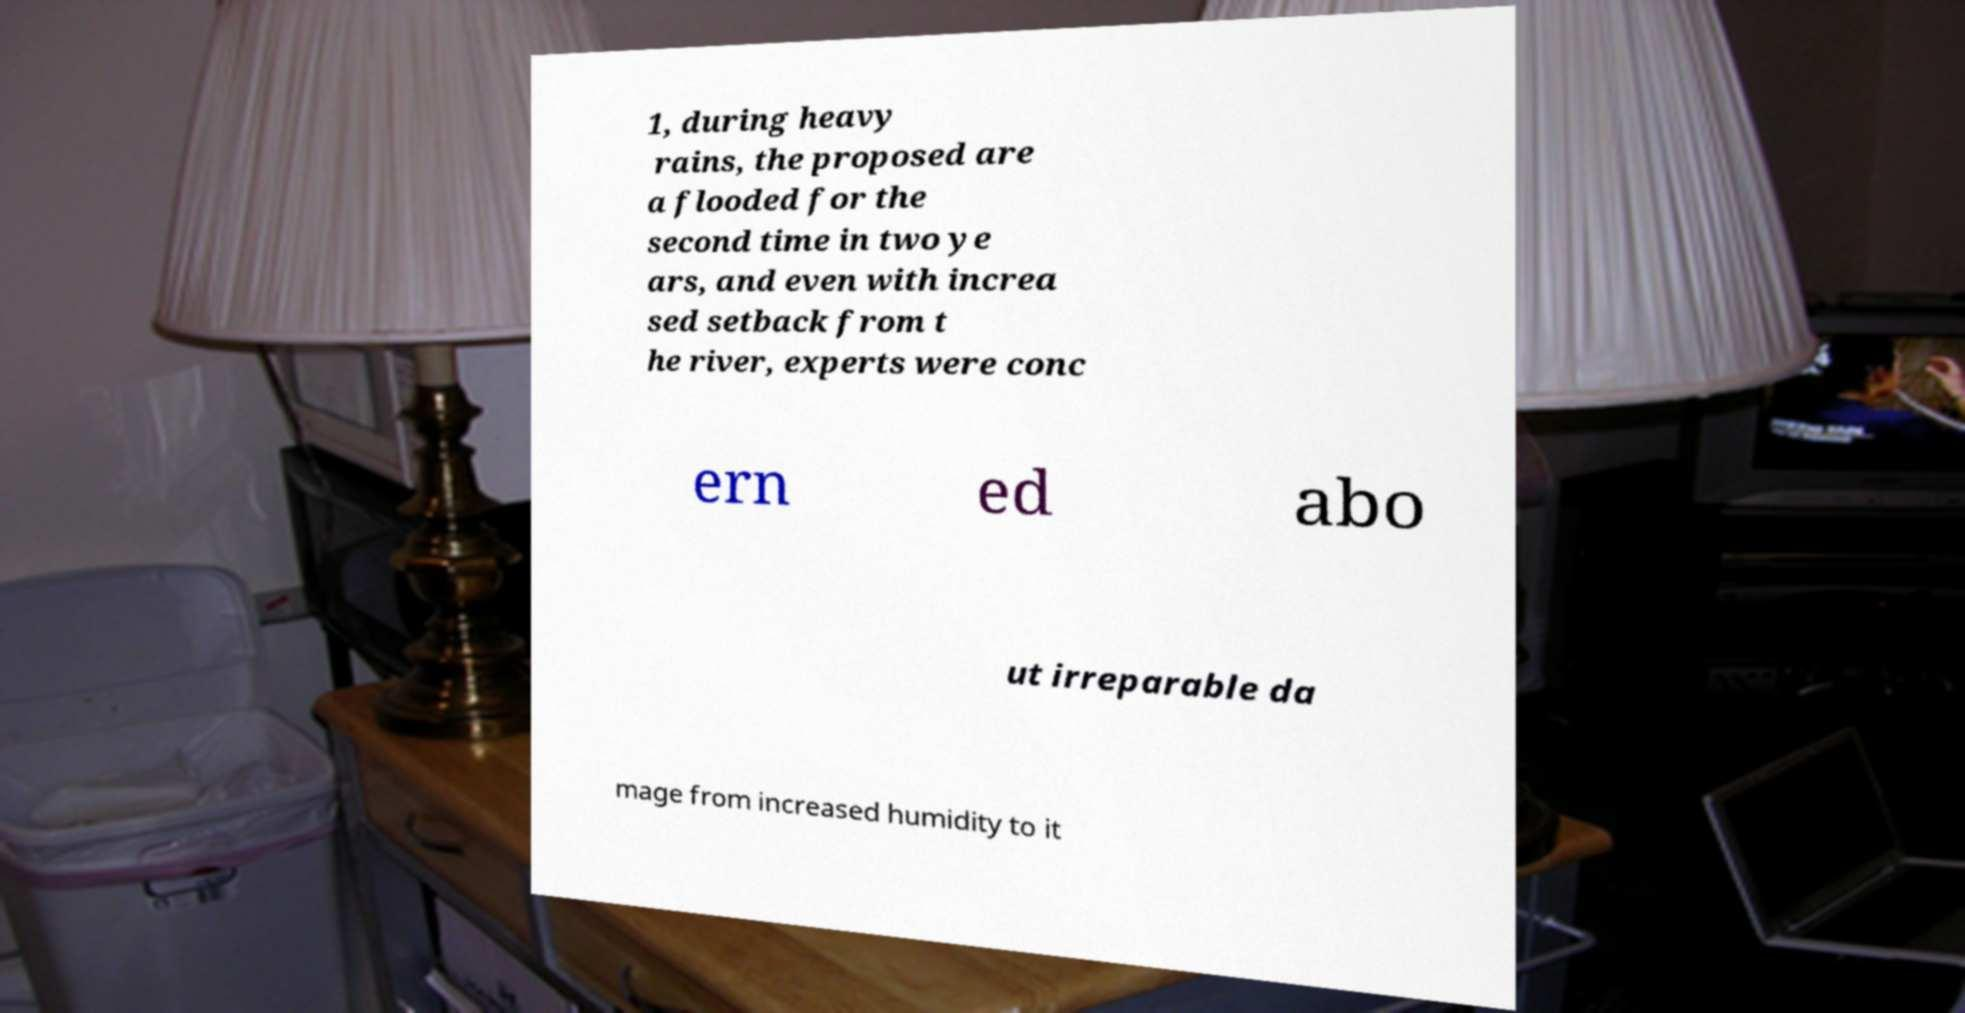What messages or text are displayed in this image? I need them in a readable, typed format. 1, during heavy rains, the proposed are a flooded for the second time in two ye ars, and even with increa sed setback from t he river, experts were conc ern ed abo ut irreparable da mage from increased humidity to it 